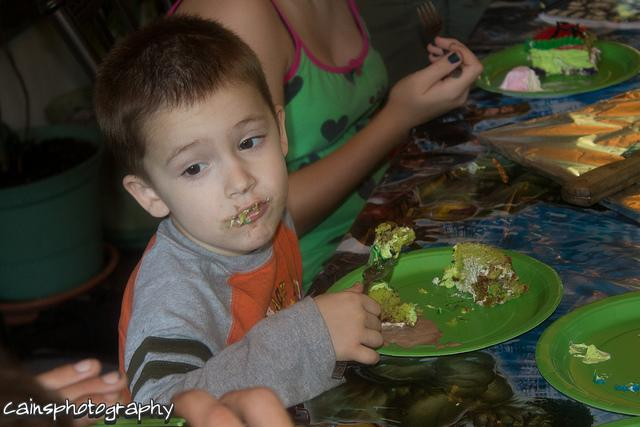If the boy overeats he will get what kind of body ache? stomach 